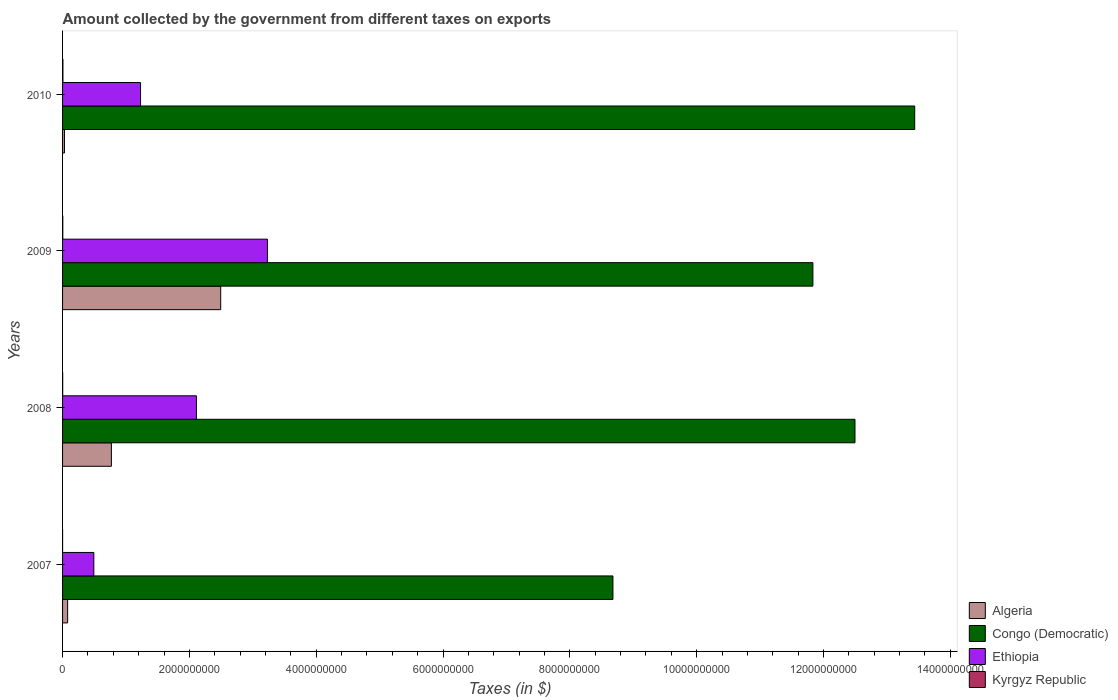How many different coloured bars are there?
Provide a short and direct response. 4. Are the number of bars per tick equal to the number of legend labels?
Your answer should be very brief. Yes. Are the number of bars on each tick of the Y-axis equal?
Offer a terse response. Yes. In how many cases, is the number of bars for a given year not equal to the number of legend labels?
Provide a succinct answer. 0. What is the amount collected by the government from taxes on exports in Kyrgyz Republic in 2007?
Your answer should be very brief. 1.46e+05. Across all years, what is the maximum amount collected by the government from taxes on exports in Ethiopia?
Provide a short and direct response. 3.23e+09. Across all years, what is the minimum amount collected by the government from taxes on exports in Congo (Democratic)?
Your response must be concise. 8.68e+09. In which year was the amount collected by the government from taxes on exports in Algeria maximum?
Provide a short and direct response. 2009. What is the total amount collected by the government from taxes on exports in Kyrgyz Republic in the graph?
Keep it short and to the point. 1.14e+07. What is the difference between the amount collected by the government from taxes on exports in Ethiopia in 2007 and that in 2009?
Keep it short and to the point. -2.74e+09. What is the difference between the amount collected by the government from taxes on exports in Ethiopia in 2009 and the amount collected by the government from taxes on exports in Kyrgyz Republic in 2007?
Your answer should be compact. 3.23e+09. What is the average amount collected by the government from taxes on exports in Congo (Democratic) per year?
Provide a succinct answer. 1.16e+1. In the year 2009, what is the difference between the amount collected by the government from taxes on exports in Ethiopia and amount collected by the government from taxes on exports in Congo (Democratic)?
Your response must be concise. -8.60e+09. In how many years, is the amount collected by the government from taxes on exports in Ethiopia greater than 2000000000 $?
Offer a very short reply. 2. What is the ratio of the amount collected by the government from taxes on exports in Congo (Democratic) in 2009 to that in 2010?
Your answer should be very brief. 0.88. Is the amount collected by the government from taxes on exports in Congo (Democratic) in 2007 less than that in 2008?
Offer a very short reply. Yes. What is the difference between the highest and the second highest amount collected by the government from taxes on exports in Congo (Democratic)?
Offer a terse response. 9.42e+08. What is the difference between the highest and the lowest amount collected by the government from taxes on exports in Algeria?
Your response must be concise. 2.46e+09. In how many years, is the amount collected by the government from taxes on exports in Algeria greater than the average amount collected by the government from taxes on exports in Algeria taken over all years?
Make the answer very short. 1. Is the sum of the amount collected by the government from taxes on exports in Kyrgyz Republic in 2007 and 2010 greater than the maximum amount collected by the government from taxes on exports in Congo (Democratic) across all years?
Ensure brevity in your answer.  No. Is it the case that in every year, the sum of the amount collected by the government from taxes on exports in Ethiopia and amount collected by the government from taxes on exports in Congo (Democratic) is greater than the sum of amount collected by the government from taxes on exports in Algeria and amount collected by the government from taxes on exports in Kyrgyz Republic?
Keep it short and to the point. No. What does the 4th bar from the top in 2010 represents?
Provide a short and direct response. Algeria. What does the 4th bar from the bottom in 2009 represents?
Provide a succinct answer. Kyrgyz Republic. Are all the bars in the graph horizontal?
Keep it short and to the point. Yes. Are the values on the major ticks of X-axis written in scientific E-notation?
Offer a very short reply. No. How many legend labels are there?
Provide a succinct answer. 4. What is the title of the graph?
Your response must be concise. Amount collected by the government from different taxes on exports. Does "St. Kitts and Nevis" appear as one of the legend labels in the graph?
Your response must be concise. No. What is the label or title of the X-axis?
Your answer should be very brief. Taxes (in $). What is the label or title of the Y-axis?
Offer a very short reply. Years. What is the Taxes (in $) of Algeria in 2007?
Ensure brevity in your answer.  8.00e+07. What is the Taxes (in $) of Congo (Democratic) in 2007?
Keep it short and to the point. 8.68e+09. What is the Taxes (in $) of Ethiopia in 2007?
Give a very brief answer. 4.93e+08. What is the Taxes (in $) of Kyrgyz Republic in 2007?
Your answer should be very brief. 1.46e+05. What is the Taxes (in $) of Algeria in 2008?
Your response must be concise. 7.70e+08. What is the Taxes (in $) in Congo (Democratic) in 2008?
Keep it short and to the point. 1.25e+1. What is the Taxes (in $) of Ethiopia in 2008?
Offer a very short reply. 2.11e+09. What is the Taxes (in $) of Kyrgyz Republic in 2008?
Your response must be concise. 1.81e+06. What is the Taxes (in $) of Algeria in 2009?
Make the answer very short. 2.49e+09. What is the Taxes (in $) in Congo (Democratic) in 2009?
Provide a succinct answer. 1.18e+1. What is the Taxes (in $) of Ethiopia in 2009?
Make the answer very short. 3.23e+09. What is the Taxes (in $) in Kyrgyz Republic in 2009?
Keep it short and to the point. 3.56e+06. What is the Taxes (in $) of Algeria in 2010?
Your response must be concise. 3.00e+07. What is the Taxes (in $) in Congo (Democratic) in 2010?
Provide a succinct answer. 1.34e+1. What is the Taxes (in $) in Ethiopia in 2010?
Provide a short and direct response. 1.23e+09. What is the Taxes (in $) of Kyrgyz Republic in 2010?
Your answer should be compact. 5.91e+06. Across all years, what is the maximum Taxes (in $) in Algeria?
Offer a terse response. 2.49e+09. Across all years, what is the maximum Taxes (in $) of Congo (Democratic)?
Provide a succinct answer. 1.34e+1. Across all years, what is the maximum Taxes (in $) in Ethiopia?
Make the answer very short. 3.23e+09. Across all years, what is the maximum Taxes (in $) of Kyrgyz Republic?
Offer a very short reply. 5.91e+06. Across all years, what is the minimum Taxes (in $) of Algeria?
Offer a terse response. 3.00e+07. Across all years, what is the minimum Taxes (in $) of Congo (Democratic)?
Ensure brevity in your answer.  8.68e+09. Across all years, what is the minimum Taxes (in $) of Ethiopia?
Your answer should be compact. 4.93e+08. Across all years, what is the minimum Taxes (in $) of Kyrgyz Republic?
Your answer should be compact. 1.46e+05. What is the total Taxes (in $) in Algeria in the graph?
Your answer should be compact. 3.37e+09. What is the total Taxes (in $) in Congo (Democratic) in the graph?
Keep it short and to the point. 4.64e+1. What is the total Taxes (in $) of Ethiopia in the graph?
Keep it short and to the point. 7.06e+09. What is the total Taxes (in $) in Kyrgyz Republic in the graph?
Make the answer very short. 1.14e+07. What is the difference between the Taxes (in $) of Algeria in 2007 and that in 2008?
Your response must be concise. -6.90e+08. What is the difference between the Taxes (in $) of Congo (Democratic) in 2007 and that in 2008?
Provide a short and direct response. -3.82e+09. What is the difference between the Taxes (in $) in Ethiopia in 2007 and that in 2008?
Give a very brief answer. -1.62e+09. What is the difference between the Taxes (in $) in Kyrgyz Republic in 2007 and that in 2008?
Ensure brevity in your answer.  -1.66e+06. What is the difference between the Taxes (in $) of Algeria in 2007 and that in 2009?
Provide a succinct answer. -2.41e+09. What is the difference between the Taxes (in $) of Congo (Democratic) in 2007 and that in 2009?
Provide a short and direct response. -3.15e+09. What is the difference between the Taxes (in $) of Ethiopia in 2007 and that in 2009?
Give a very brief answer. -2.74e+09. What is the difference between the Taxes (in $) in Kyrgyz Republic in 2007 and that in 2009?
Your answer should be very brief. -3.42e+06. What is the difference between the Taxes (in $) of Algeria in 2007 and that in 2010?
Your answer should be very brief. 5.00e+07. What is the difference between the Taxes (in $) in Congo (Democratic) in 2007 and that in 2010?
Your answer should be compact. -4.76e+09. What is the difference between the Taxes (in $) in Ethiopia in 2007 and that in 2010?
Your answer should be compact. -7.37e+08. What is the difference between the Taxes (in $) of Kyrgyz Republic in 2007 and that in 2010?
Your response must be concise. -5.77e+06. What is the difference between the Taxes (in $) of Algeria in 2008 and that in 2009?
Your answer should be compact. -1.72e+09. What is the difference between the Taxes (in $) in Congo (Democratic) in 2008 and that in 2009?
Ensure brevity in your answer.  6.64e+08. What is the difference between the Taxes (in $) of Ethiopia in 2008 and that in 2009?
Your answer should be compact. -1.12e+09. What is the difference between the Taxes (in $) of Kyrgyz Republic in 2008 and that in 2009?
Make the answer very short. -1.76e+06. What is the difference between the Taxes (in $) of Algeria in 2008 and that in 2010?
Your answer should be compact. 7.40e+08. What is the difference between the Taxes (in $) in Congo (Democratic) in 2008 and that in 2010?
Your answer should be compact. -9.42e+08. What is the difference between the Taxes (in $) of Ethiopia in 2008 and that in 2010?
Keep it short and to the point. 8.81e+08. What is the difference between the Taxes (in $) in Kyrgyz Republic in 2008 and that in 2010?
Make the answer very short. -4.11e+06. What is the difference between the Taxes (in $) in Algeria in 2009 and that in 2010?
Your answer should be compact. 2.46e+09. What is the difference between the Taxes (in $) in Congo (Democratic) in 2009 and that in 2010?
Provide a short and direct response. -1.61e+09. What is the difference between the Taxes (in $) in Ethiopia in 2009 and that in 2010?
Your response must be concise. 2.00e+09. What is the difference between the Taxes (in $) of Kyrgyz Republic in 2009 and that in 2010?
Provide a succinct answer. -2.35e+06. What is the difference between the Taxes (in $) in Algeria in 2007 and the Taxes (in $) in Congo (Democratic) in 2008?
Offer a very short reply. -1.24e+1. What is the difference between the Taxes (in $) of Algeria in 2007 and the Taxes (in $) of Ethiopia in 2008?
Provide a succinct answer. -2.03e+09. What is the difference between the Taxes (in $) in Algeria in 2007 and the Taxes (in $) in Kyrgyz Republic in 2008?
Give a very brief answer. 7.82e+07. What is the difference between the Taxes (in $) of Congo (Democratic) in 2007 and the Taxes (in $) of Ethiopia in 2008?
Your response must be concise. 6.57e+09. What is the difference between the Taxes (in $) of Congo (Democratic) in 2007 and the Taxes (in $) of Kyrgyz Republic in 2008?
Your response must be concise. 8.68e+09. What is the difference between the Taxes (in $) of Ethiopia in 2007 and the Taxes (in $) of Kyrgyz Republic in 2008?
Provide a short and direct response. 4.91e+08. What is the difference between the Taxes (in $) in Algeria in 2007 and the Taxes (in $) in Congo (Democratic) in 2009?
Provide a short and direct response. -1.18e+1. What is the difference between the Taxes (in $) of Algeria in 2007 and the Taxes (in $) of Ethiopia in 2009?
Provide a short and direct response. -3.15e+09. What is the difference between the Taxes (in $) in Algeria in 2007 and the Taxes (in $) in Kyrgyz Republic in 2009?
Give a very brief answer. 7.64e+07. What is the difference between the Taxes (in $) in Congo (Democratic) in 2007 and the Taxes (in $) in Ethiopia in 2009?
Give a very brief answer. 5.45e+09. What is the difference between the Taxes (in $) of Congo (Democratic) in 2007 and the Taxes (in $) of Kyrgyz Republic in 2009?
Offer a very short reply. 8.68e+09. What is the difference between the Taxes (in $) of Ethiopia in 2007 and the Taxes (in $) of Kyrgyz Republic in 2009?
Offer a terse response. 4.90e+08. What is the difference between the Taxes (in $) in Algeria in 2007 and the Taxes (in $) in Congo (Democratic) in 2010?
Ensure brevity in your answer.  -1.34e+1. What is the difference between the Taxes (in $) in Algeria in 2007 and the Taxes (in $) in Ethiopia in 2010?
Keep it short and to the point. -1.15e+09. What is the difference between the Taxes (in $) of Algeria in 2007 and the Taxes (in $) of Kyrgyz Republic in 2010?
Offer a terse response. 7.41e+07. What is the difference between the Taxes (in $) of Congo (Democratic) in 2007 and the Taxes (in $) of Ethiopia in 2010?
Provide a succinct answer. 7.45e+09. What is the difference between the Taxes (in $) of Congo (Democratic) in 2007 and the Taxes (in $) of Kyrgyz Republic in 2010?
Provide a short and direct response. 8.67e+09. What is the difference between the Taxes (in $) in Ethiopia in 2007 and the Taxes (in $) in Kyrgyz Republic in 2010?
Make the answer very short. 4.87e+08. What is the difference between the Taxes (in $) in Algeria in 2008 and the Taxes (in $) in Congo (Democratic) in 2009?
Provide a succinct answer. -1.11e+1. What is the difference between the Taxes (in $) of Algeria in 2008 and the Taxes (in $) of Ethiopia in 2009?
Provide a succinct answer. -2.46e+09. What is the difference between the Taxes (in $) in Algeria in 2008 and the Taxes (in $) in Kyrgyz Republic in 2009?
Offer a terse response. 7.66e+08. What is the difference between the Taxes (in $) of Congo (Democratic) in 2008 and the Taxes (in $) of Ethiopia in 2009?
Provide a succinct answer. 9.27e+09. What is the difference between the Taxes (in $) of Congo (Democratic) in 2008 and the Taxes (in $) of Kyrgyz Republic in 2009?
Make the answer very short. 1.25e+1. What is the difference between the Taxes (in $) in Ethiopia in 2008 and the Taxes (in $) in Kyrgyz Republic in 2009?
Offer a terse response. 2.11e+09. What is the difference between the Taxes (in $) of Algeria in 2008 and the Taxes (in $) of Congo (Democratic) in 2010?
Keep it short and to the point. -1.27e+1. What is the difference between the Taxes (in $) of Algeria in 2008 and the Taxes (in $) of Ethiopia in 2010?
Your answer should be very brief. -4.60e+08. What is the difference between the Taxes (in $) in Algeria in 2008 and the Taxes (in $) in Kyrgyz Republic in 2010?
Provide a short and direct response. 7.64e+08. What is the difference between the Taxes (in $) in Congo (Democratic) in 2008 and the Taxes (in $) in Ethiopia in 2010?
Your answer should be compact. 1.13e+1. What is the difference between the Taxes (in $) in Congo (Democratic) in 2008 and the Taxes (in $) in Kyrgyz Republic in 2010?
Your answer should be compact. 1.25e+1. What is the difference between the Taxes (in $) in Ethiopia in 2008 and the Taxes (in $) in Kyrgyz Republic in 2010?
Make the answer very short. 2.11e+09. What is the difference between the Taxes (in $) in Algeria in 2009 and the Taxes (in $) in Congo (Democratic) in 2010?
Give a very brief answer. -1.09e+1. What is the difference between the Taxes (in $) of Algeria in 2009 and the Taxes (in $) of Ethiopia in 2010?
Keep it short and to the point. 1.26e+09. What is the difference between the Taxes (in $) of Algeria in 2009 and the Taxes (in $) of Kyrgyz Republic in 2010?
Make the answer very short. 2.49e+09. What is the difference between the Taxes (in $) in Congo (Democratic) in 2009 and the Taxes (in $) in Ethiopia in 2010?
Your response must be concise. 1.06e+1. What is the difference between the Taxes (in $) of Congo (Democratic) in 2009 and the Taxes (in $) of Kyrgyz Republic in 2010?
Offer a terse response. 1.18e+1. What is the difference between the Taxes (in $) in Ethiopia in 2009 and the Taxes (in $) in Kyrgyz Republic in 2010?
Your response must be concise. 3.22e+09. What is the average Taxes (in $) in Algeria per year?
Give a very brief answer. 8.43e+08. What is the average Taxes (in $) in Congo (Democratic) per year?
Provide a succinct answer. 1.16e+1. What is the average Taxes (in $) of Ethiopia per year?
Offer a very short reply. 1.77e+09. What is the average Taxes (in $) of Kyrgyz Republic per year?
Give a very brief answer. 2.86e+06. In the year 2007, what is the difference between the Taxes (in $) of Algeria and Taxes (in $) of Congo (Democratic)?
Give a very brief answer. -8.60e+09. In the year 2007, what is the difference between the Taxes (in $) of Algeria and Taxes (in $) of Ethiopia?
Your response must be concise. -4.13e+08. In the year 2007, what is the difference between the Taxes (in $) in Algeria and Taxes (in $) in Kyrgyz Republic?
Make the answer very short. 7.99e+07. In the year 2007, what is the difference between the Taxes (in $) of Congo (Democratic) and Taxes (in $) of Ethiopia?
Make the answer very short. 8.19e+09. In the year 2007, what is the difference between the Taxes (in $) of Congo (Democratic) and Taxes (in $) of Kyrgyz Republic?
Provide a succinct answer. 8.68e+09. In the year 2007, what is the difference between the Taxes (in $) in Ethiopia and Taxes (in $) in Kyrgyz Republic?
Your answer should be compact. 4.93e+08. In the year 2008, what is the difference between the Taxes (in $) of Algeria and Taxes (in $) of Congo (Democratic)?
Provide a short and direct response. -1.17e+1. In the year 2008, what is the difference between the Taxes (in $) of Algeria and Taxes (in $) of Ethiopia?
Keep it short and to the point. -1.34e+09. In the year 2008, what is the difference between the Taxes (in $) in Algeria and Taxes (in $) in Kyrgyz Republic?
Your answer should be very brief. 7.68e+08. In the year 2008, what is the difference between the Taxes (in $) in Congo (Democratic) and Taxes (in $) in Ethiopia?
Provide a short and direct response. 1.04e+1. In the year 2008, what is the difference between the Taxes (in $) of Congo (Democratic) and Taxes (in $) of Kyrgyz Republic?
Your response must be concise. 1.25e+1. In the year 2008, what is the difference between the Taxes (in $) of Ethiopia and Taxes (in $) of Kyrgyz Republic?
Your response must be concise. 2.11e+09. In the year 2009, what is the difference between the Taxes (in $) in Algeria and Taxes (in $) in Congo (Democratic)?
Your response must be concise. -9.34e+09. In the year 2009, what is the difference between the Taxes (in $) in Algeria and Taxes (in $) in Ethiopia?
Provide a short and direct response. -7.37e+08. In the year 2009, what is the difference between the Taxes (in $) in Algeria and Taxes (in $) in Kyrgyz Republic?
Offer a very short reply. 2.49e+09. In the year 2009, what is the difference between the Taxes (in $) in Congo (Democratic) and Taxes (in $) in Ethiopia?
Ensure brevity in your answer.  8.60e+09. In the year 2009, what is the difference between the Taxes (in $) of Congo (Democratic) and Taxes (in $) of Kyrgyz Republic?
Offer a very short reply. 1.18e+1. In the year 2009, what is the difference between the Taxes (in $) in Ethiopia and Taxes (in $) in Kyrgyz Republic?
Ensure brevity in your answer.  3.23e+09. In the year 2010, what is the difference between the Taxes (in $) in Algeria and Taxes (in $) in Congo (Democratic)?
Your answer should be very brief. -1.34e+1. In the year 2010, what is the difference between the Taxes (in $) in Algeria and Taxes (in $) in Ethiopia?
Make the answer very short. -1.20e+09. In the year 2010, what is the difference between the Taxes (in $) of Algeria and Taxes (in $) of Kyrgyz Republic?
Offer a terse response. 2.41e+07. In the year 2010, what is the difference between the Taxes (in $) of Congo (Democratic) and Taxes (in $) of Ethiopia?
Provide a succinct answer. 1.22e+1. In the year 2010, what is the difference between the Taxes (in $) of Congo (Democratic) and Taxes (in $) of Kyrgyz Republic?
Provide a succinct answer. 1.34e+1. In the year 2010, what is the difference between the Taxes (in $) of Ethiopia and Taxes (in $) of Kyrgyz Republic?
Provide a short and direct response. 1.22e+09. What is the ratio of the Taxes (in $) in Algeria in 2007 to that in 2008?
Keep it short and to the point. 0.1. What is the ratio of the Taxes (in $) in Congo (Democratic) in 2007 to that in 2008?
Ensure brevity in your answer.  0.69. What is the ratio of the Taxes (in $) of Ethiopia in 2007 to that in 2008?
Offer a very short reply. 0.23. What is the ratio of the Taxes (in $) in Kyrgyz Republic in 2007 to that in 2008?
Offer a terse response. 0.08. What is the ratio of the Taxes (in $) in Algeria in 2007 to that in 2009?
Your response must be concise. 0.03. What is the ratio of the Taxes (in $) in Congo (Democratic) in 2007 to that in 2009?
Offer a very short reply. 0.73. What is the ratio of the Taxes (in $) in Ethiopia in 2007 to that in 2009?
Your response must be concise. 0.15. What is the ratio of the Taxes (in $) in Kyrgyz Republic in 2007 to that in 2009?
Your answer should be compact. 0.04. What is the ratio of the Taxes (in $) of Algeria in 2007 to that in 2010?
Your response must be concise. 2.67. What is the ratio of the Taxes (in $) in Congo (Democratic) in 2007 to that in 2010?
Keep it short and to the point. 0.65. What is the ratio of the Taxes (in $) in Ethiopia in 2007 to that in 2010?
Your answer should be compact. 0.4. What is the ratio of the Taxes (in $) of Kyrgyz Republic in 2007 to that in 2010?
Give a very brief answer. 0.02. What is the ratio of the Taxes (in $) in Algeria in 2008 to that in 2009?
Your answer should be compact. 0.31. What is the ratio of the Taxes (in $) of Congo (Democratic) in 2008 to that in 2009?
Provide a short and direct response. 1.06. What is the ratio of the Taxes (in $) of Ethiopia in 2008 to that in 2009?
Your answer should be compact. 0.65. What is the ratio of the Taxes (in $) of Kyrgyz Republic in 2008 to that in 2009?
Ensure brevity in your answer.  0.51. What is the ratio of the Taxes (in $) of Algeria in 2008 to that in 2010?
Provide a succinct answer. 25.67. What is the ratio of the Taxes (in $) of Congo (Democratic) in 2008 to that in 2010?
Ensure brevity in your answer.  0.93. What is the ratio of the Taxes (in $) in Ethiopia in 2008 to that in 2010?
Your answer should be very brief. 1.72. What is the ratio of the Taxes (in $) in Kyrgyz Republic in 2008 to that in 2010?
Offer a very short reply. 0.31. What is the ratio of the Taxes (in $) in Algeria in 2009 to that in 2010?
Provide a succinct answer. 83.12. What is the ratio of the Taxes (in $) in Congo (Democratic) in 2009 to that in 2010?
Give a very brief answer. 0.88. What is the ratio of the Taxes (in $) in Ethiopia in 2009 to that in 2010?
Give a very brief answer. 2.63. What is the ratio of the Taxes (in $) in Kyrgyz Republic in 2009 to that in 2010?
Provide a succinct answer. 0.6. What is the difference between the highest and the second highest Taxes (in $) in Algeria?
Keep it short and to the point. 1.72e+09. What is the difference between the highest and the second highest Taxes (in $) in Congo (Democratic)?
Make the answer very short. 9.42e+08. What is the difference between the highest and the second highest Taxes (in $) in Ethiopia?
Give a very brief answer. 1.12e+09. What is the difference between the highest and the second highest Taxes (in $) in Kyrgyz Republic?
Provide a succinct answer. 2.35e+06. What is the difference between the highest and the lowest Taxes (in $) in Algeria?
Provide a succinct answer. 2.46e+09. What is the difference between the highest and the lowest Taxes (in $) in Congo (Democratic)?
Offer a very short reply. 4.76e+09. What is the difference between the highest and the lowest Taxes (in $) in Ethiopia?
Your answer should be compact. 2.74e+09. What is the difference between the highest and the lowest Taxes (in $) of Kyrgyz Republic?
Keep it short and to the point. 5.77e+06. 